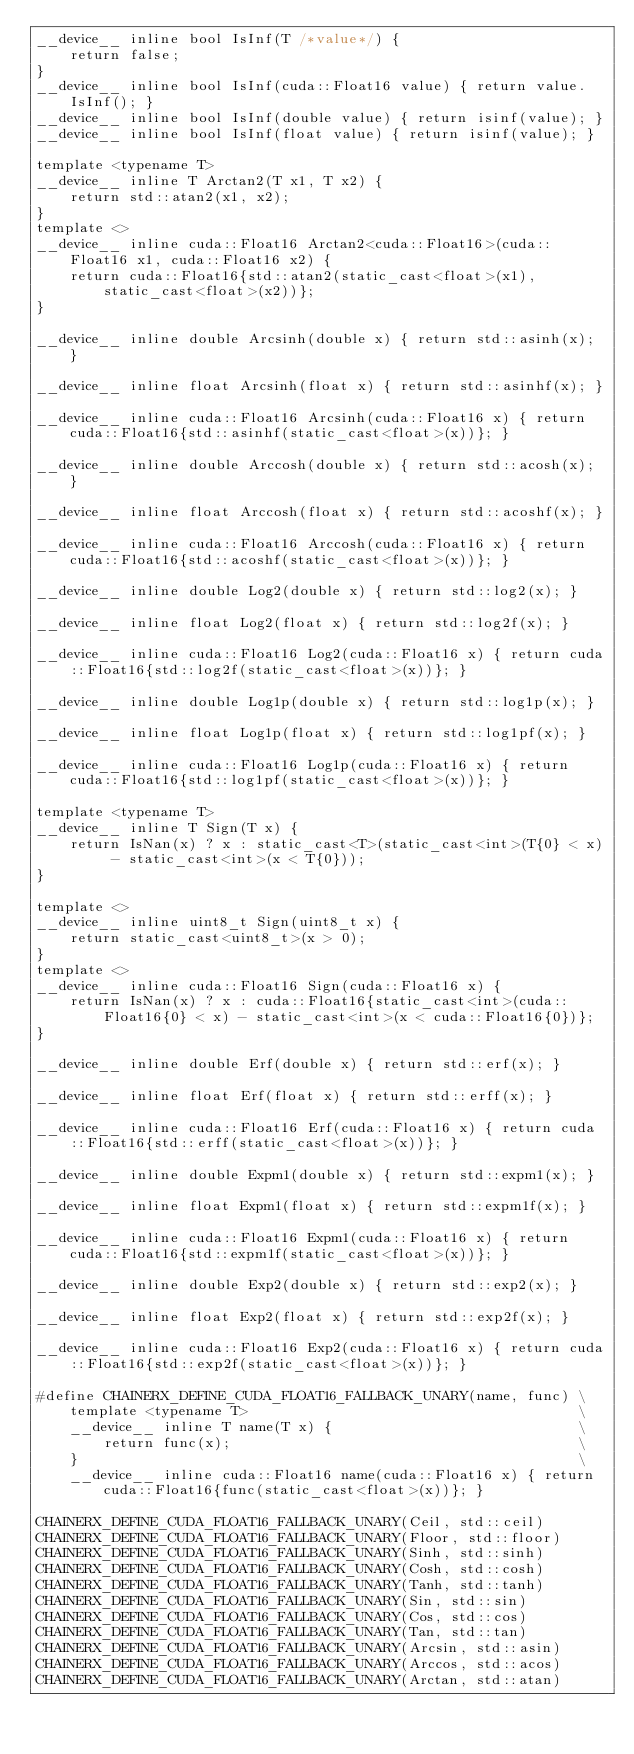<code> <loc_0><loc_0><loc_500><loc_500><_Cuda_>__device__ inline bool IsInf(T /*value*/) {
    return false;
}
__device__ inline bool IsInf(cuda::Float16 value) { return value.IsInf(); }
__device__ inline bool IsInf(double value) { return isinf(value); }
__device__ inline bool IsInf(float value) { return isinf(value); }

template <typename T>
__device__ inline T Arctan2(T x1, T x2) {
    return std::atan2(x1, x2);
}
template <>
__device__ inline cuda::Float16 Arctan2<cuda::Float16>(cuda::Float16 x1, cuda::Float16 x2) {
    return cuda::Float16{std::atan2(static_cast<float>(x1), static_cast<float>(x2))};
}

__device__ inline double Arcsinh(double x) { return std::asinh(x); }

__device__ inline float Arcsinh(float x) { return std::asinhf(x); }

__device__ inline cuda::Float16 Arcsinh(cuda::Float16 x) { return cuda::Float16{std::asinhf(static_cast<float>(x))}; }

__device__ inline double Arccosh(double x) { return std::acosh(x); }

__device__ inline float Arccosh(float x) { return std::acoshf(x); }

__device__ inline cuda::Float16 Arccosh(cuda::Float16 x) { return cuda::Float16{std::acoshf(static_cast<float>(x))}; }

__device__ inline double Log2(double x) { return std::log2(x); }

__device__ inline float Log2(float x) { return std::log2f(x); }

__device__ inline cuda::Float16 Log2(cuda::Float16 x) { return cuda::Float16{std::log2f(static_cast<float>(x))}; }

__device__ inline double Log1p(double x) { return std::log1p(x); }

__device__ inline float Log1p(float x) { return std::log1pf(x); }

__device__ inline cuda::Float16 Log1p(cuda::Float16 x) { return cuda::Float16{std::log1pf(static_cast<float>(x))}; }

template <typename T>
__device__ inline T Sign(T x) {
    return IsNan(x) ? x : static_cast<T>(static_cast<int>(T{0} < x) - static_cast<int>(x < T{0}));
}

template <>
__device__ inline uint8_t Sign(uint8_t x) {
    return static_cast<uint8_t>(x > 0);
}
template <>
__device__ inline cuda::Float16 Sign(cuda::Float16 x) {
    return IsNan(x) ? x : cuda::Float16{static_cast<int>(cuda::Float16{0} < x) - static_cast<int>(x < cuda::Float16{0})};
}

__device__ inline double Erf(double x) { return std::erf(x); }

__device__ inline float Erf(float x) { return std::erff(x); }

__device__ inline cuda::Float16 Erf(cuda::Float16 x) { return cuda::Float16{std::erff(static_cast<float>(x))}; }

__device__ inline double Expm1(double x) { return std::expm1(x); }

__device__ inline float Expm1(float x) { return std::expm1f(x); }

__device__ inline cuda::Float16 Expm1(cuda::Float16 x) { return cuda::Float16{std::expm1f(static_cast<float>(x))}; }

__device__ inline double Exp2(double x) { return std::exp2(x); }

__device__ inline float Exp2(float x) { return std::exp2f(x); }

__device__ inline cuda::Float16 Exp2(cuda::Float16 x) { return cuda::Float16{std::exp2f(static_cast<float>(x))}; }

#define CHAINERX_DEFINE_CUDA_FLOAT16_FALLBACK_UNARY(name, func) \
    template <typename T>                                       \
    __device__ inline T name(T x) {                             \
        return func(x);                                         \
    }                                                           \
    __device__ inline cuda::Float16 name(cuda::Float16 x) { return cuda::Float16{func(static_cast<float>(x))}; }

CHAINERX_DEFINE_CUDA_FLOAT16_FALLBACK_UNARY(Ceil, std::ceil)
CHAINERX_DEFINE_CUDA_FLOAT16_FALLBACK_UNARY(Floor, std::floor)
CHAINERX_DEFINE_CUDA_FLOAT16_FALLBACK_UNARY(Sinh, std::sinh)
CHAINERX_DEFINE_CUDA_FLOAT16_FALLBACK_UNARY(Cosh, std::cosh)
CHAINERX_DEFINE_CUDA_FLOAT16_FALLBACK_UNARY(Tanh, std::tanh)
CHAINERX_DEFINE_CUDA_FLOAT16_FALLBACK_UNARY(Sin, std::sin)
CHAINERX_DEFINE_CUDA_FLOAT16_FALLBACK_UNARY(Cos, std::cos)
CHAINERX_DEFINE_CUDA_FLOAT16_FALLBACK_UNARY(Tan, std::tan)
CHAINERX_DEFINE_CUDA_FLOAT16_FALLBACK_UNARY(Arcsin, std::asin)
CHAINERX_DEFINE_CUDA_FLOAT16_FALLBACK_UNARY(Arccos, std::acos)
CHAINERX_DEFINE_CUDA_FLOAT16_FALLBACK_UNARY(Arctan, std::atan)</code> 